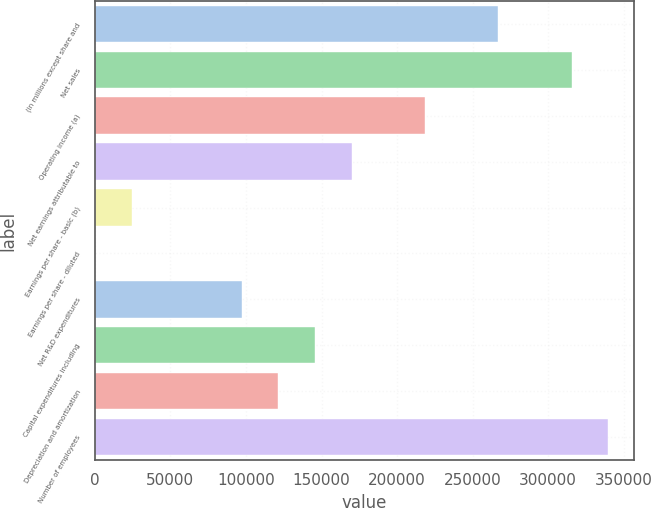<chart> <loc_0><loc_0><loc_500><loc_500><bar_chart><fcel>(in millions except share and<fcel>Net sales<fcel>Operating income (a)<fcel>Net earnings attributable to<fcel>Earnings per share - basic (b)<fcel>Earnings per share - diluted<fcel>Net R&D expenditures<fcel>Capital expenditures including<fcel>Depreciation and amortization<fcel>Number of employees<nl><fcel>267029<fcel>315580<fcel>218479<fcel>169928<fcel>24277.3<fcel>2.09<fcel>97102.9<fcel>145653<fcel>121378<fcel>339855<nl></chart> 